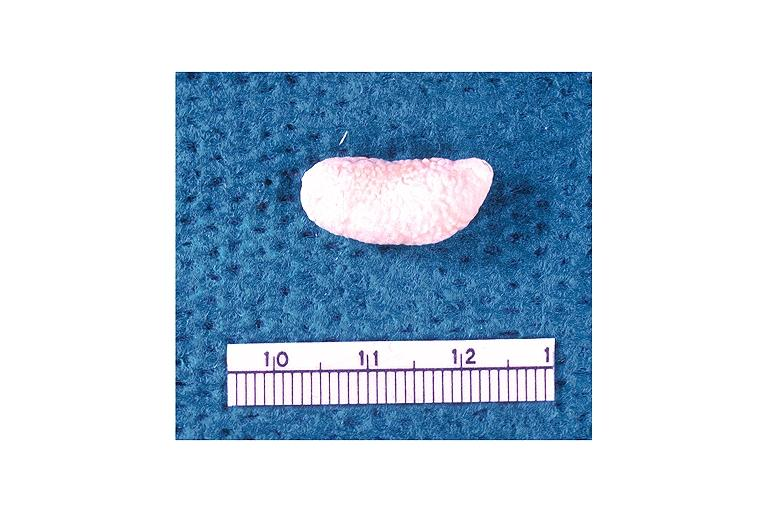where is this?
Answer the question using a single word or phrase. Oral 